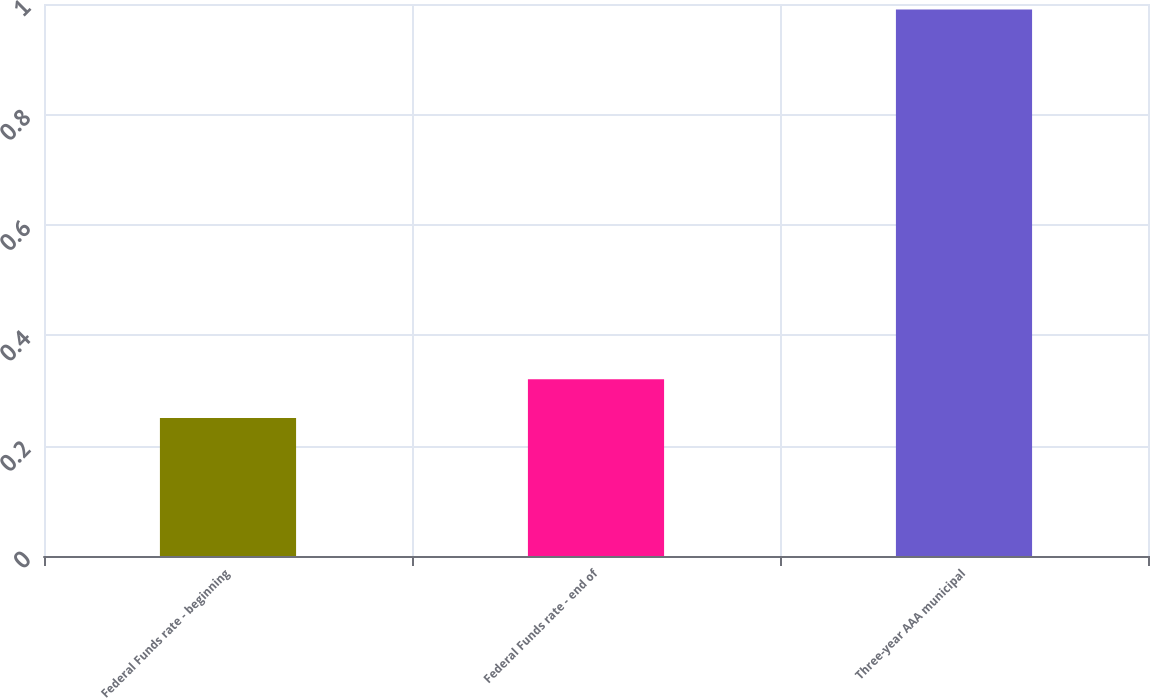Convert chart to OTSL. <chart><loc_0><loc_0><loc_500><loc_500><bar_chart><fcel>Federal Funds rate - beginning<fcel>Federal Funds rate - end of<fcel>Three-year AAA municipal<nl><fcel>0.25<fcel>0.32<fcel>0.99<nl></chart> 